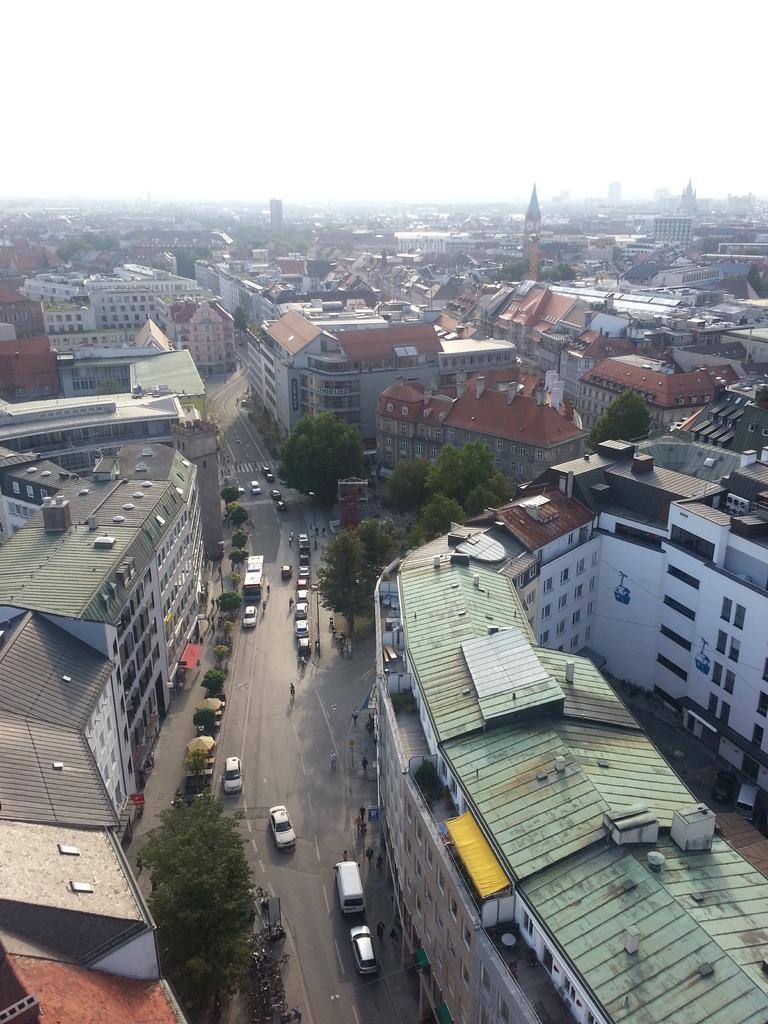In one or two sentences, can you explain what this image depicts? In this image I can see few buildings,windows,trees and few vehicles on the road. I can see few people are walking on the road. The sky is in white color. 